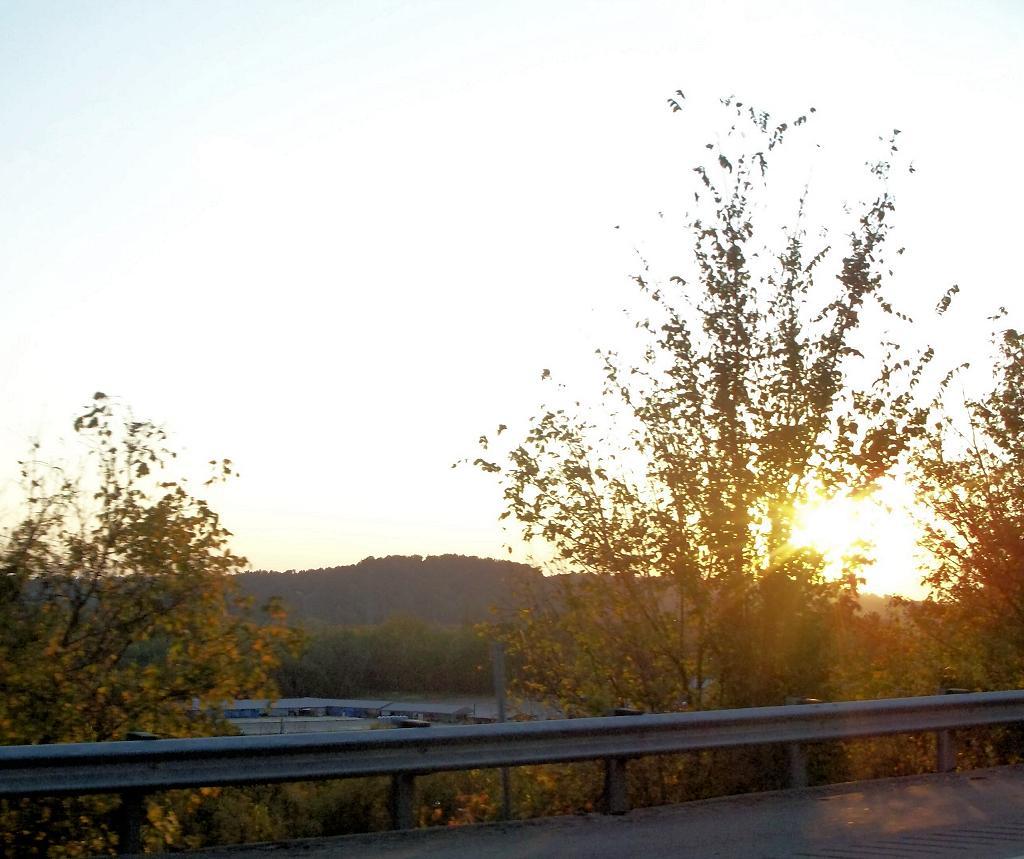Please provide a concise description of this image. In this picture I can see few trees and I can see hill and looks like buildings and I can see sunlight in the sky and I can see metal fence. 